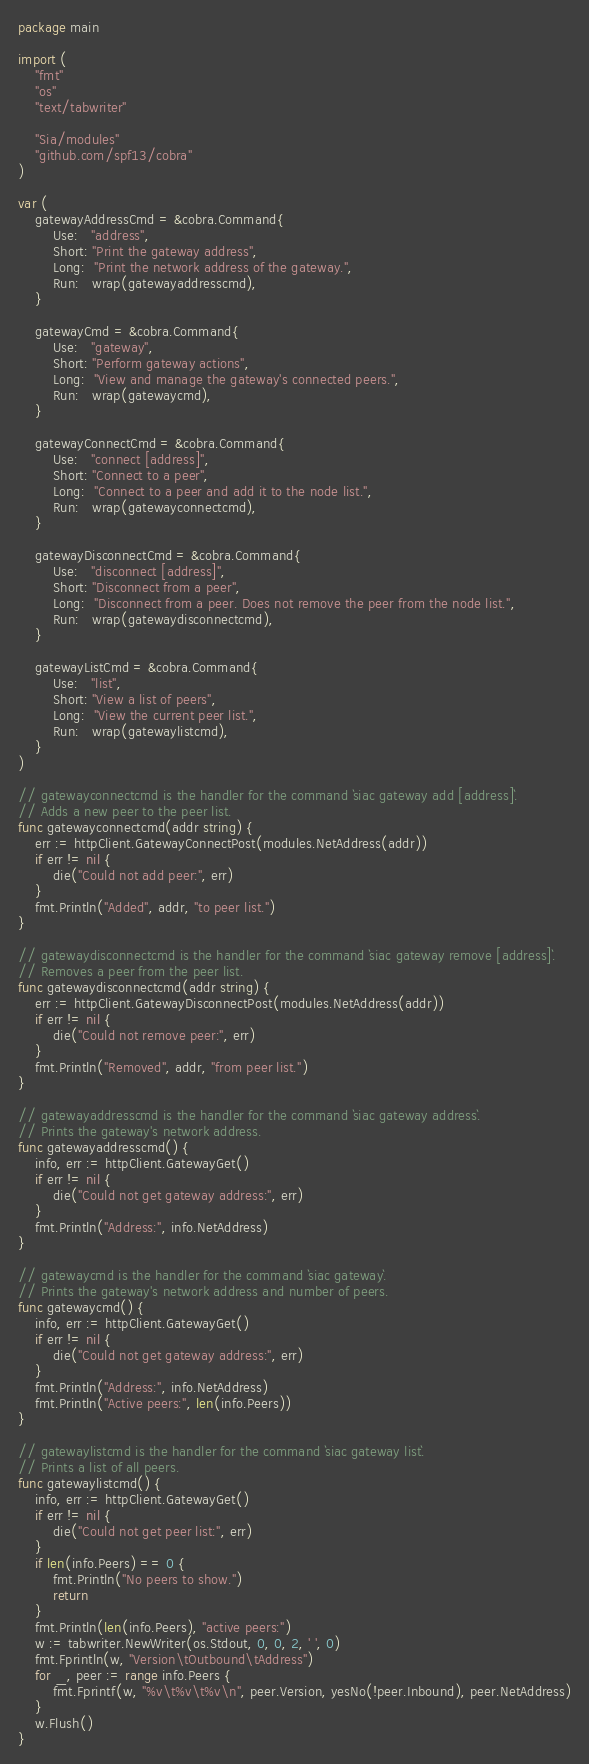<code> <loc_0><loc_0><loc_500><loc_500><_Go_>package main

import (
	"fmt"
	"os"
	"text/tabwriter"

	"Sia/modules"
	"github.com/spf13/cobra"
)

var (
	gatewayAddressCmd = &cobra.Command{
		Use:   "address",
		Short: "Print the gateway address",
		Long:  "Print the network address of the gateway.",
		Run:   wrap(gatewayaddresscmd),
	}

	gatewayCmd = &cobra.Command{
		Use:   "gateway",
		Short: "Perform gateway actions",
		Long:  "View and manage the gateway's connected peers.",
		Run:   wrap(gatewaycmd),
	}

	gatewayConnectCmd = &cobra.Command{
		Use:   "connect [address]",
		Short: "Connect to a peer",
		Long:  "Connect to a peer and add it to the node list.",
		Run:   wrap(gatewayconnectcmd),
	}

	gatewayDisconnectCmd = &cobra.Command{
		Use:   "disconnect [address]",
		Short: "Disconnect from a peer",
		Long:  "Disconnect from a peer. Does not remove the peer from the node list.",
		Run:   wrap(gatewaydisconnectcmd),
	}

	gatewayListCmd = &cobra.Command{
		Use:   "list",
		Short: "View a list of peers",
		Long:  "View the current peer list.",
		Run:   wrap(gatewaylistcmd),
	}
)

// gatewayconnectcmd is the handler for the command `siac gateway add [address]`.
// Adds a new peer to the peer list.
func gatewayconnectcmd(addr string) {
	err := httpClient.GatewayConnectPost(modules.NetAddress(addr))
	if err != nil {
		die("Could not add peer:", err)
	}
	fmt.Println("Added", addr, "to peer list.")
}

// gatewaydisconnectcmd is the handler for the command `siac gateway remove [address]`.
// Removes a peer from the peer list.
func gatewaydisconnectcmd(addr string) {
	err := httpClient.GatewayDisconnectPost(modules.NetAddress(addr))
	if err != nil {
		die("Could not remove peer:", err)
	}
	fmt.Println("Removed", addr, "from peer list.")
}

// gatewayaddresscmd is the handler for the command `siac gateway address`.
// Prints the gateway's network address.
func gatewayaddresscmd() {
	info, err := httpClient.GatewayGet()
	if err != nil {
		die("Could not get gateway address:", err)
	}
	fmt.Println("Address:", info.NetAddress)
}

// gatewaycmd is the handler for the command `siac gateway`.
// Prints the gateway's network address and number of peers.
func gatewaycmd() {
	info, err := httpClient.GatewayGet()
	if err != nil {
		die("Could not get gateway address:", err)
	}
	fmt.Println("Address:", info.NetAddress)
	fmt.Println("Active peers:", len(info.Peers))
}

// gatewaylistcmd is the handler for the command `siac gateway list`.
// Prints a list of all peers.
func gatewaylistcmd() {
	info, err := httpClient.GatewayGet()
	if err != nil {
		die("Could not get peer list:", err)
	}
	if len(info.Peers) == 0 {
		fmt.Println("No peers to show.")
		return
	}
	fmt.Println(len(info.Peers), "active peers:")
	w := tabwriter.NewWriter(os.Stdout, 0, 0, 2, ' ', 0)
	fmt.Fprintln(w, "Version\tOutbound\tAddress")
	for _, peer := range info.Peers {
		fmt.Fprintf(w, "%v\t%v\t%v\n", peer.Version, yesNo(!peer.Inbound), peer.NetAddress)
	}
	w.Flush()
}
</code> 